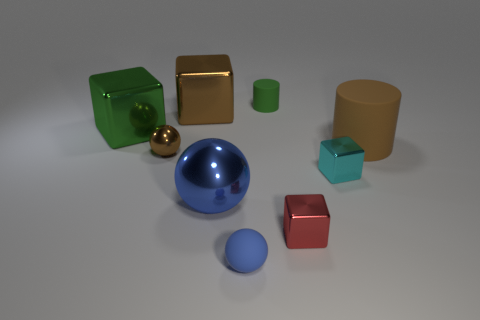Is the number of blue matte balls in front of the matte sphere less than the number of large yellow matte blocks?
Provide a succinct answer. No. There is a green thing that is left of the small metallic thing that is on the left side of the tiny object that is behind the big rubber cylinder; what is its material?
Your response must be concise. Metal. Are there more large shiny cubes on the right side of the tiny brown metallic sphere than small green things that are in front of the blue shiny sphere?
Offer a terse response. Yes. What number of rubber things are cyan blocks or big red balls?
Give a very brief answer. 0. The thing that is the same color as the tiny matte ball is what shape?
Ensure brevity in your answer.  Sphere. What is the block that is in front of the cyan cube made of?
Offer a very short reply. Metal. How many objects are small blue matte spheres or large objects that are behind the large blue thing?
Your answer should be very brief. 4. The green object that is the same size as the red object is what shape?
Your answer should be very brief. Cylinder. How many big objects have the same color as the tiny shiny sphere?
Your response must be concise. 2. Does the object in front of the red metallic object have the same material as the big green block?
Offer a terse response. No. 